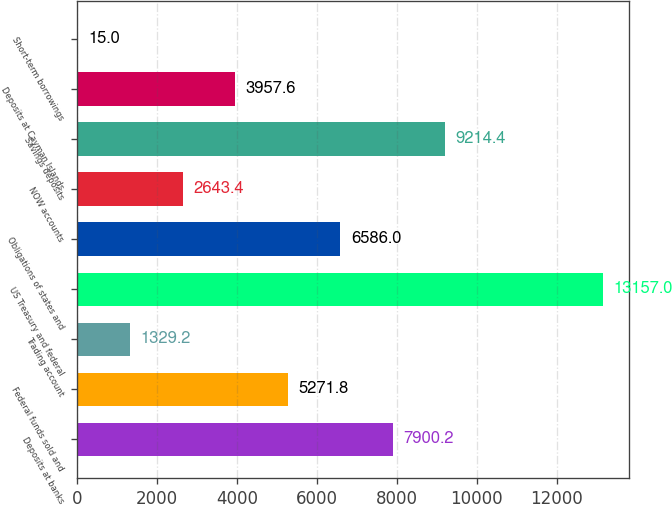Convert chart to OTSL. <chart><loc_0><loc_0><loc_500><loc_500><bar_chart><fcel>Deposits at banks<fcel>Federal funds sold and<fcel>Trading account<fcel>US Treasury and federal<fcel>Obligations of states and<fcel>NOW accounts<fcel>Savings deposits<fcel>Deposits at Cayman Islands<fcel>Short-term borrowings<nl><fcel>7900.2<fcel>5271.8<fcel>1329.2<fcel>13157<fcel>6586<fcel>2643.4<fcel>9214.4<fcel>3957.6<fcel>15<nl></chart> 